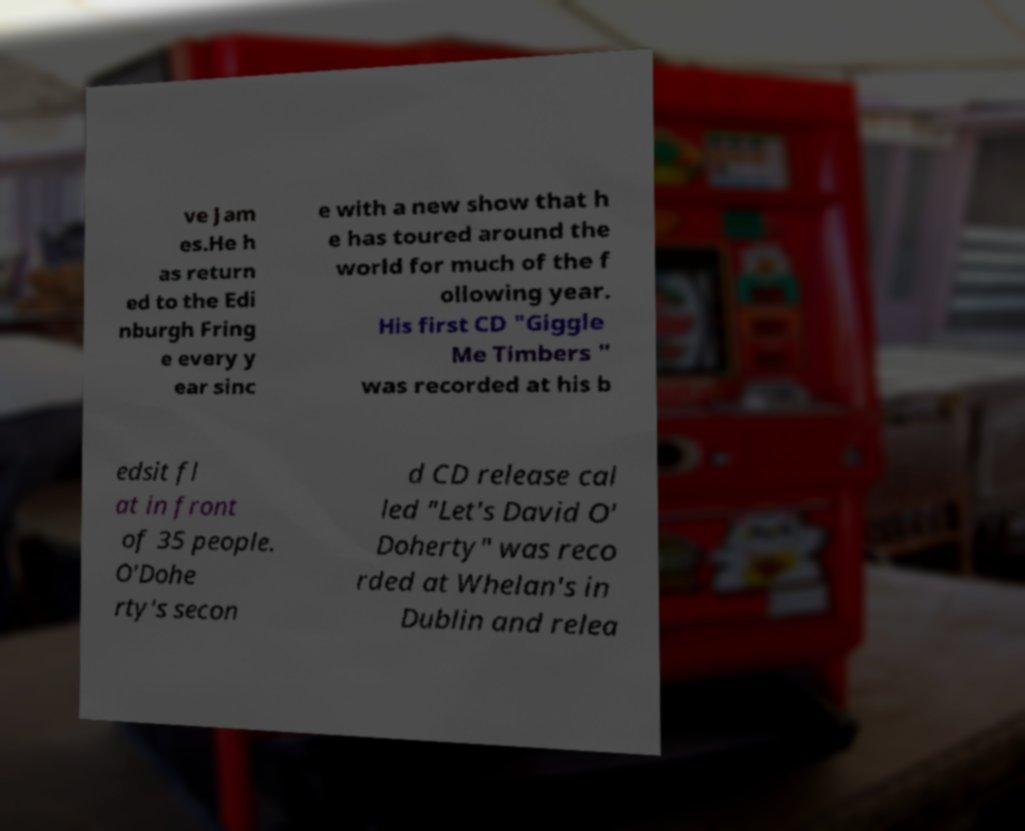I need the written content from this picture converted into text. Can you do that? ve Jam es.He h as return ed to the Edi nburgh Fring e every y ear sinc e with a new show that h e has toured around the world for much of the f ollowing year. His first CD "Giggle Me Timbers " was recorded at his b edsit fl at in front of 35 people. O'Dohe rty's secon d CD release cal led "Let's David O' Doherty" was reco rded at Whelan's in Dublin and relea 